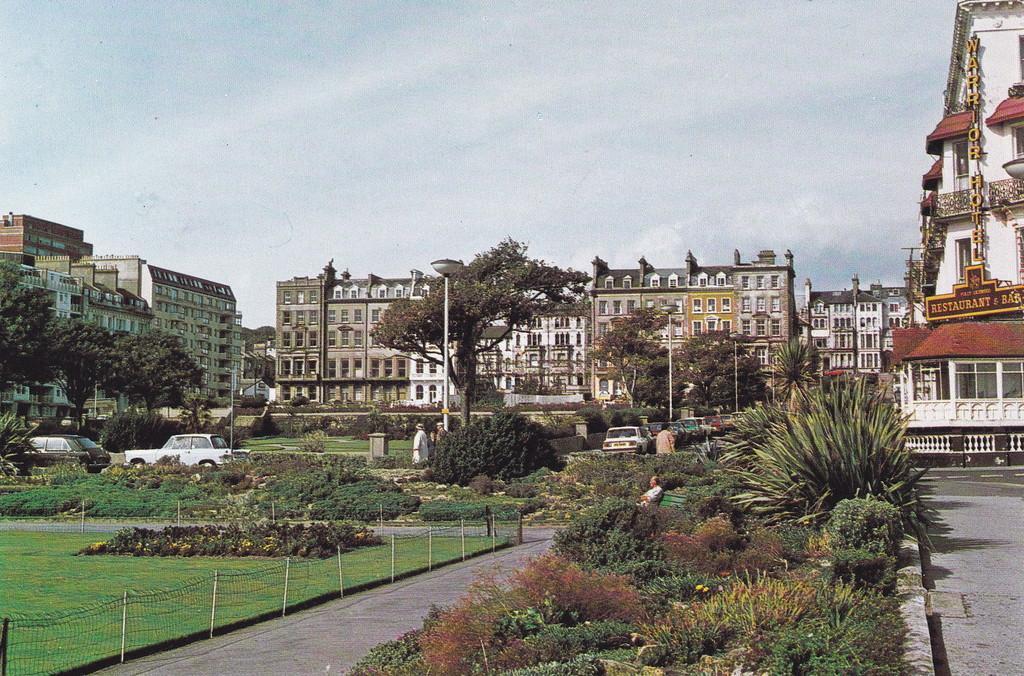Could you give a brief overview of what you see in this image? In this image we can see the garden area with some plants and trees and there are some people. We can see some vehicles on the road and there are few street lights and in the background, we can see some buildings, at the top there is a sky. 